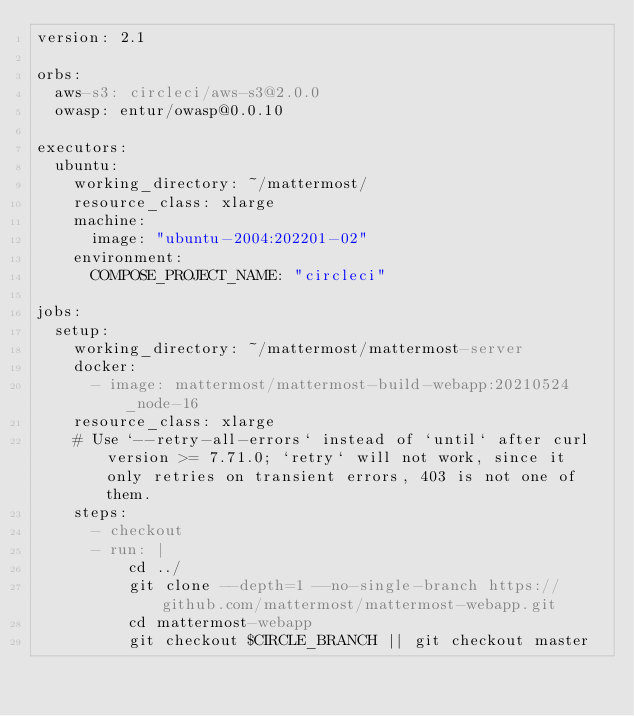<code> <loc_0><loc_0><loc_500><loc_500><_YAML_>version: 2.1

orbs:
  aws-s3: circleci/aws-s3@2.0.0
  owasp: entur/owasp@0.0.10

executors:
  ubuntu:
    working_directory: ~/mattermost/
    resource_class: xlarge
    machine:
      image: "ubuntu-2004:202201-02"
    environment:
      COMPOSE_PROJECT_NAME: "circleci"

jobs:
  setup:
    working_directory: ~/mattermost/mattermost-server
    docker:
      - image: mattermost/mattermost-build-webapp:20210524_node-16
    resource_class: xlarge
    # Use `--retry-all-errors` instead of `until` after curl version >= 7.71.0; `retry` will not work, since it only retries on transient errors, 403 is not one of them.
    steps:
      - checkout
      - run: |
          cd ../
          git clone --depth=1 --no-single-branch https://github.com/mattermost/mattermost-webapp.git
          cd mattermost-webapp
          git checkout $CIRCLE_BRANCH || git checkout master</code> 